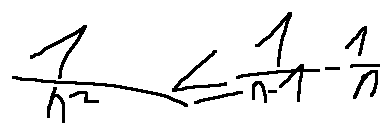Convert formula to latex. <formula><loc_0><loc_0><loc_500><loc_500>\frac { 1 } { n ^ { 2 } } \leq \frac { 1 } { n - 1 } - \frac { 1 } { n }</formula> 